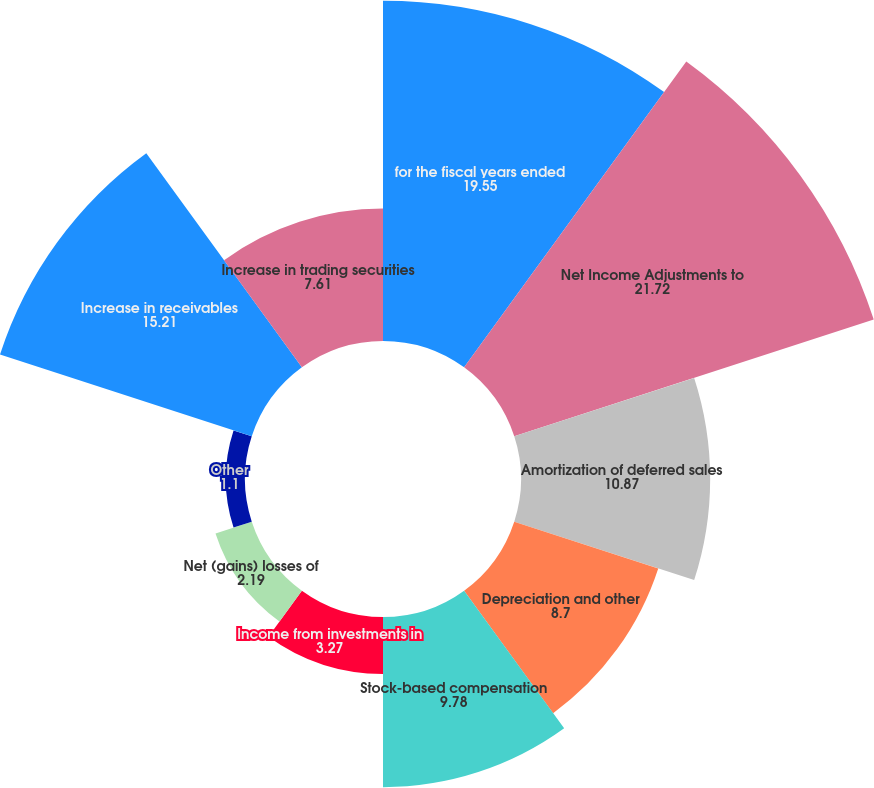Convert chart. <chart><loc_0><loc_0><loc_500><loc_500><pie_chart><fcel>for the fiscal years ended<fcel>Net Income Adjustments to<fcel>Amortization of deferred sales<fcel>Depreciation and other<fcel>Stock-based compensation<fcel>Income from investments in<fcel>Net (gains) losses of<fcel>Other<fcel>Increase in receivables<fcel>Increase in trading securities<nl><fcel>19.55%<fcel>21.72%<fcel>10.87%<fcel>8.7%<fcel>9.78%<fcel>3.27%<fcel>2.19%<fcel>1.1%<fcel>15.21%<fcel>7.61%<nl></chart> 